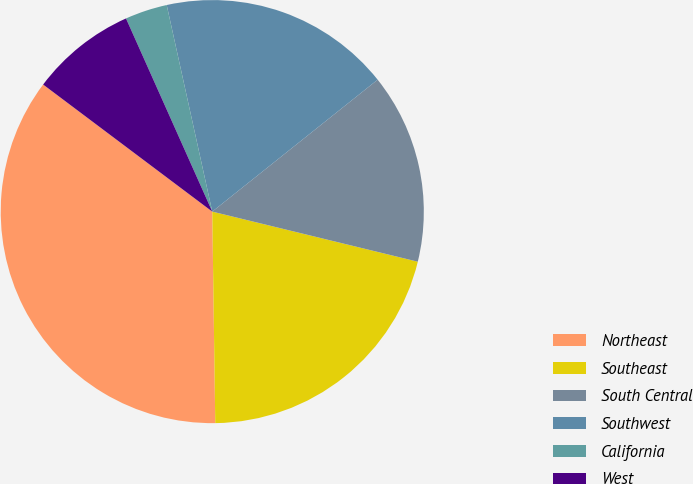Convert chart. <chart><loc_0><loc_0><loc_500><loc_500><pie_chart><fcel>Northeast<fcel>Southeast<fcel>South Central<fcel>Southwest<fcel>California<fcel>West<nl><fcel>35.48%<fcel>20.97%<fcel>14.52%<fcel>17.74%<fcel>3.23%<fcel>8.06%<nl></chart> 